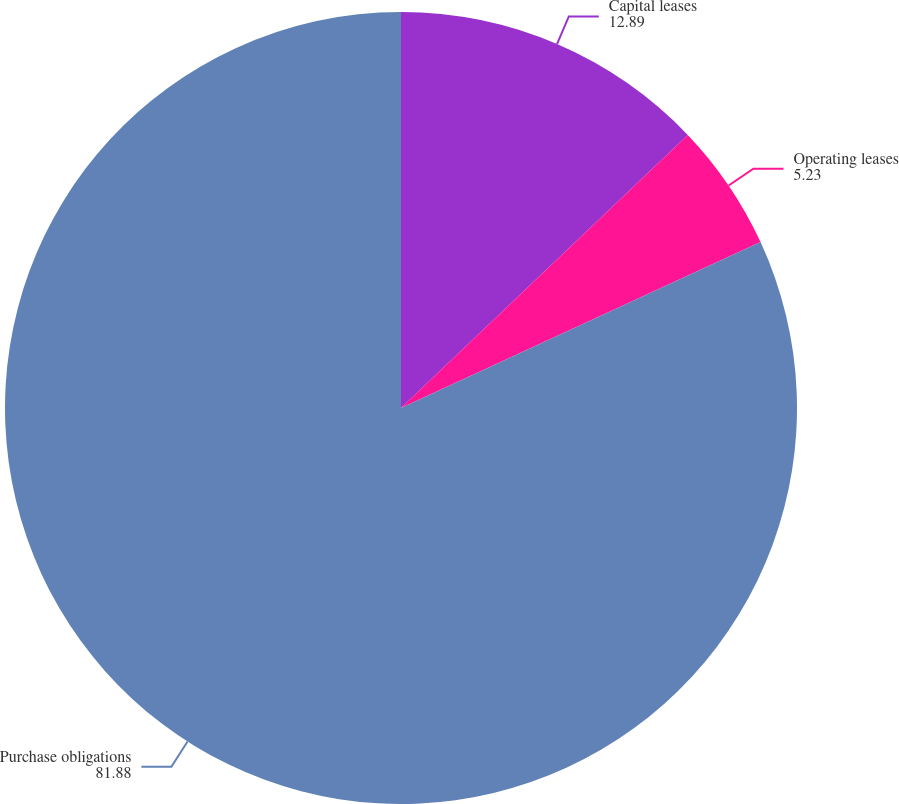Convert chart. <chart><loc_0><loc_0><loc_500><loc_500><pie_chart><fcel>Capital leases<fcel>Operating leases<fcel>Purchase obligations<nl><fcel>12.89%<fcel>5.23%<fcel>81.88%<nl></chart> 